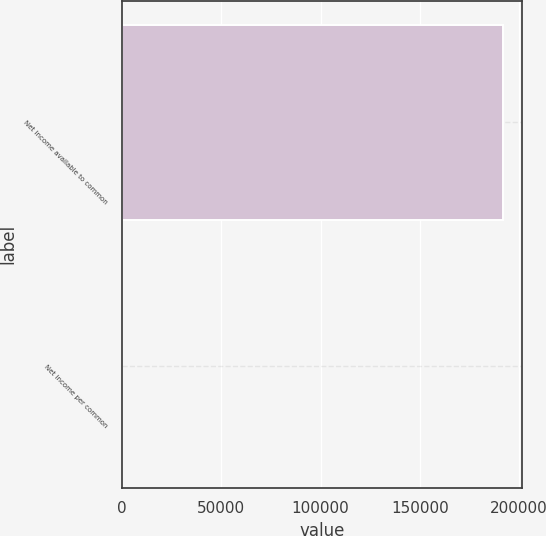Convert chart. <chart><loc_0><loc_0><loc_500><loc_500><bar_chart><fcel>Net income available to common<fcel>Net income per common<nl><fcel>191973<fcel>2.08<nl></chart> 